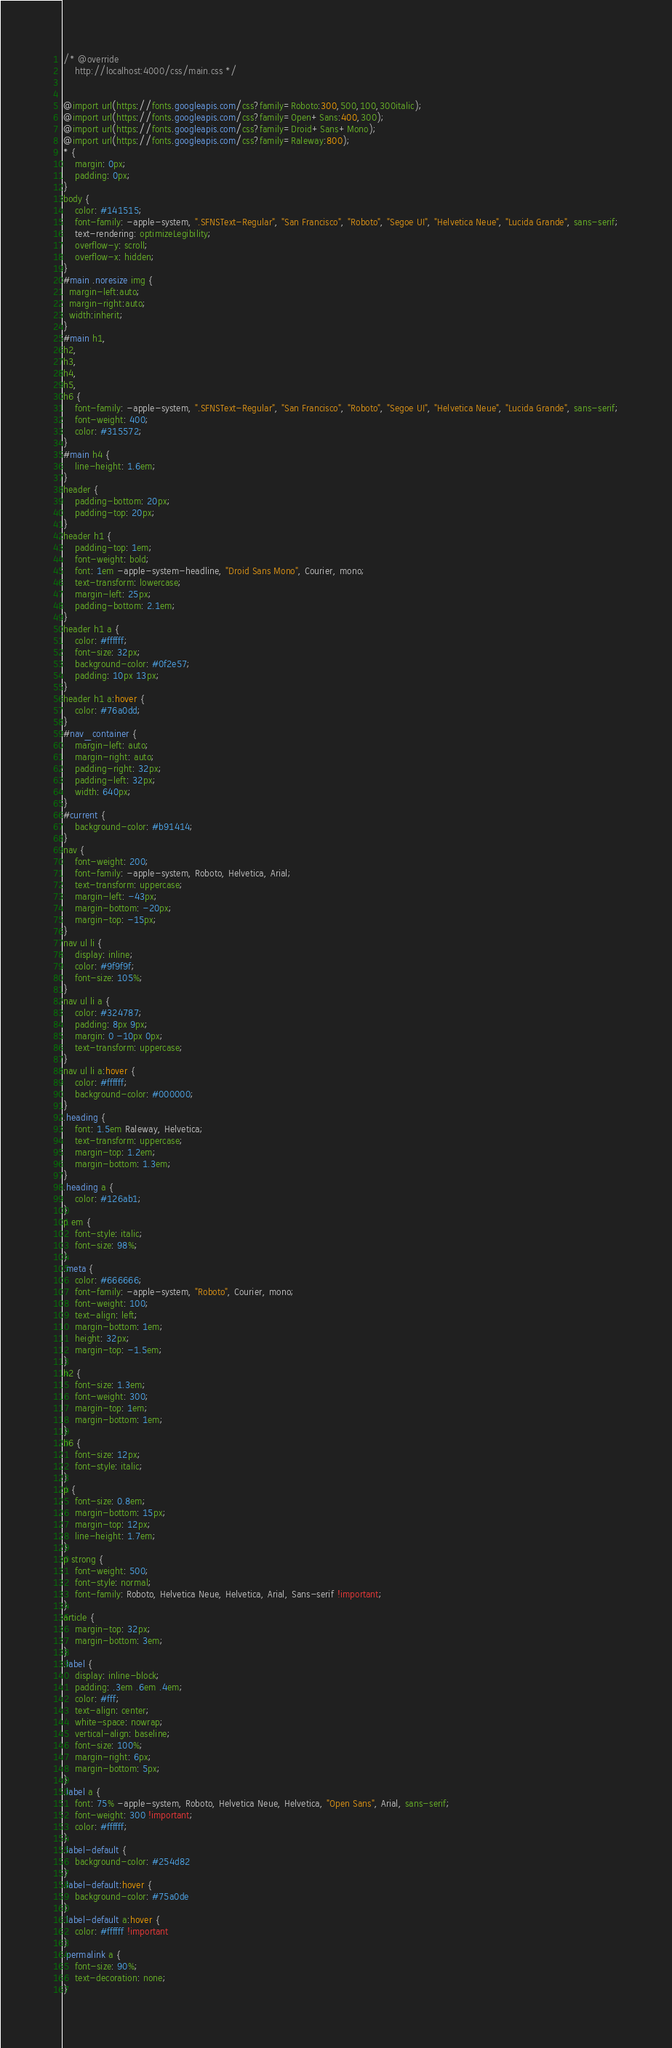Convert code to text. <code><loc_0><loc_0><loc_500><loc_500><_CSS_>/* @override 
	http://localhost:4000/css/main.css */


@import url(https://fonts.googleapis.com/css?family=Roboto:300,500,100,300italic);
@import url(https://fonts.googleapis.com/css?family=Open+Sans:400,300);
@import url(https://fonts.googleapis.com/css?family=Droid+Sans+Mono);
@import url(https://fonts.googleapis.com/css?family=Raleway:800);
* {
    margin: 0px;
    padding: 0px;
}
body {
    color: #141515;
    font-family: -apple-system, ".SFNSText-Regular", "San Francisco", "Roboto", "Segoe UI", "Helvetica Neue", "Lucida Grande", sans-serif;
    text-rendering: optimizeLegibility;
    overflow-y: scroll;
    overflow-x: hidden;
}
#main .noresize img {
  margin-left:auto;
  margin-right:auto;
  width:inherit;
}
#main h1,
h2,
h3,
h4,
h5,
h6 {
    font-family: -apple-system, ".SFNSText-Regular", "San Francisco", "Roboto", "Segoe UI", "Helvetica Neue", "Lucida Grande", sans-serif;
    font-weight: 400;
    color: #315572;
}
#main h4 {
    line-height: 1.6em;
}
header {
    padding-bottom: 20px;
    padding-top: 20px;
}
header h1 {
    padding-top: 1em;
    font-weight: bold;
    font: 1em -apple-system-headline, "Droid Sans Mono", Courier, mono;
    text-transform: lowercase;
    margin-left: 25px;
    padding-bottom: 2.1em;
}
header h1 a {
    color: #ffffff;
    font-size: 32px;
    background-color: #0f2e57;
    padding: 10px 13px;
}
header h1 a:hover {
    color: #76a0dd;
}
#nav_container {
    margin-left: auto;
    margin-right: auto;
	padding-right: 32px;
	padding-left: 32px;
	width: 640px;
}
#current {
    background-color: #b91414;
}
nav {
    font-weight: 200;
    font-family: -apple-system, Roboto, Helvetica, Arial;
    text-transform: uppercase;
    margin-left: -43px;
	margin-bottom: -20px;
	margin-top: -15px;
}
nav ul li {
    display: inline;
    color: #9f9f9f;
	font-size: 105%;
}
nav ul li a {
    color: #324787;
    padding: 8px 9px;
    margin: 0 -10px 0px;
    text-transform: uppercase;
}
nav ul li a:hover {
    color: #ffffff;
    background-color: #000000;
}
.heading {
    font: 1.5em Raleway, Helvetica;
    text-transform: uppercase;
    margin-top: 1.2em;
    margin-bottom: 1.3em;
}
.heading a {
    color: #126ab1;
}
p em {
    font-style: italic;
	font-size: 98%;
}
.meta {
    color: #666666;
    font-family: -apple-system, "Roboto", Courier, mono;
    font-weight: 100;
    text-align: left;
    margin-bottom: 1em;
    height: 32px;
    margin-top: -1.5em;
}
h2 {
    font-size: 1.3em;
    font-weight: 300;
    margin-top: 1em;
    margin-bottom: 1em;
}
h6 {
    font-size: 12px;
    font-style: italic;
}
p {
    font-size: 0.8em;
    margin-bottom: 15px;
    margin-top: 12px;
    line-height: 1.7em;
}
p strong {
    font-weight: 500;
    font-style: normal;
    font-family: Roboto, Helvetica Neue, Helvetica, Arial, Sans-serif !important;
}
article {
    margin-top: 32px;
    margin-bottom: 3em;
}
.label {
    display: inline-block;
    padding: .3em .6em .4em;
    color: #fff;
    text-align: center;
    white-space: nowrap;
    vertical-align: baseline;
    font-size: 100%;
    margin-right: 6px;
    margin-bottom: 5px;
}
.label a {
    font: 75% -apple-system, Roboto, Helvetica Neue, Helvetica, "Open Sans", Arial, sans-serif;
    font-weight: 300 !important;
    color: #ffffff;
}
.label-default {
    background-color: #254d82
}
.label-default:hover {
    background-color: #75a0de
}
.label-default a:hover {
    color: #ffffff !important
}
.permalink a {
    font-size: 90%;
    text-decoration: none;
}</code> 